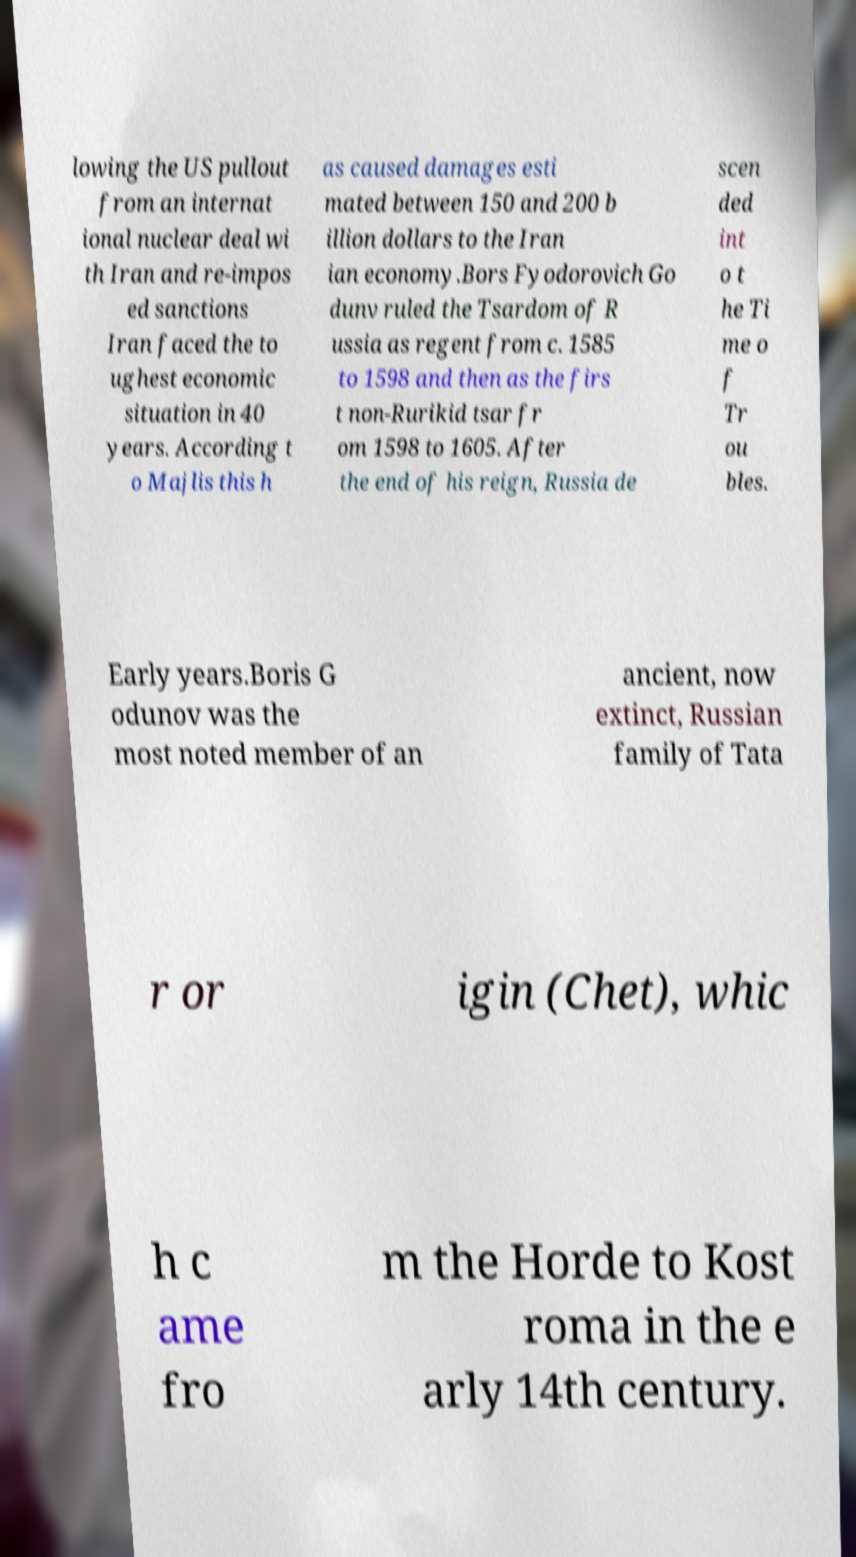Please read and relay the text visible in this image. What does it say? lowing the US pullout from an internat ional nuclear deal wi th Iran and re-impos ed sanctions Iran faced the to ughest economic situation in 40 years. According t o Majlis this h as caused damages esti mated between 150 and 200 b illion dollars to the Iran ian economy.Bors Fyodorovich Go dunv ruled the Tsardom of R ussia as regent from c. 1585 to 1598 and then as the firs t non-Rurikid tsar fr om 1598 to 1605. After the end of his reign, Russia de scen ded int o t he Ti me o f Tr ou bles. Early years.Boris G odunov was the most noted member of an ancient, now extinct, Russian family of Tata r or igin (Chet), whic h c ame fro m the Horde to Kost roma in the e arly 14th century. 